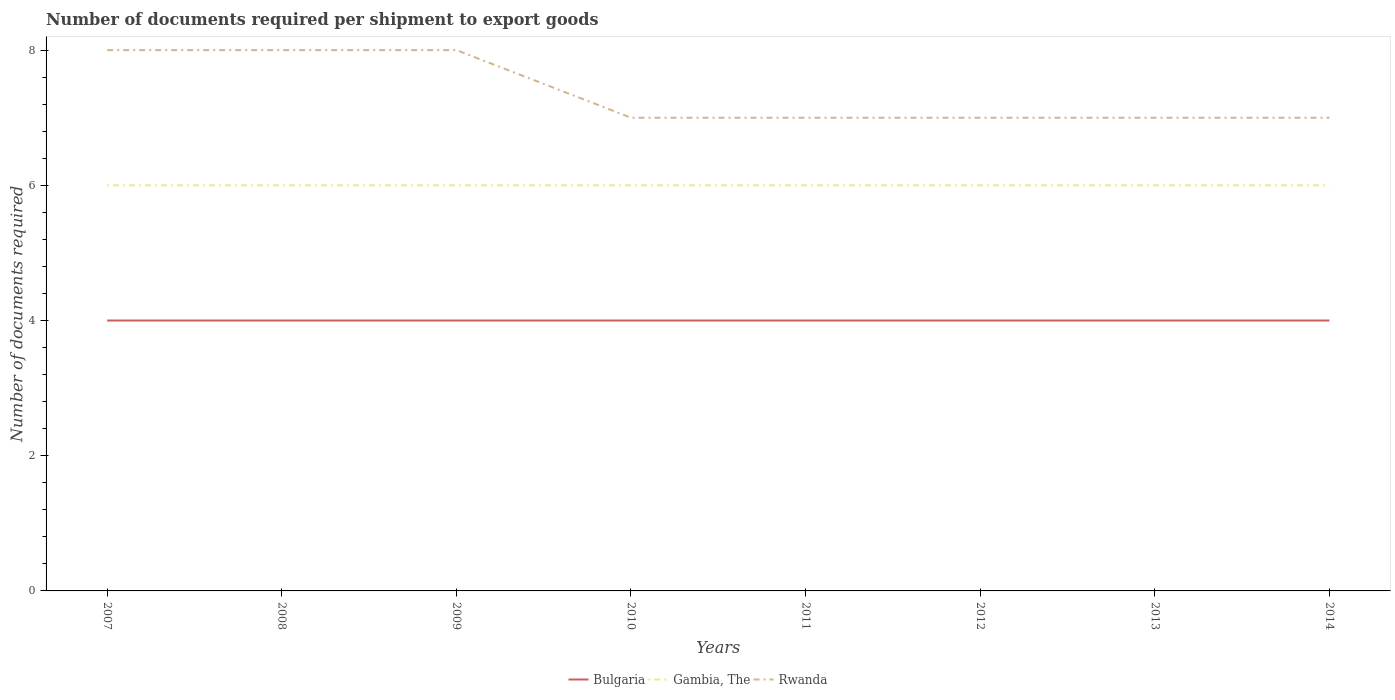How many different coloured lines are there?
Your response must be concise. 3. Is the number of lines equal to the number of legend labels?
Your answer should be very brief. Yes. Across all years, what is the maximum number of documents required per shipment to export goods in Rwanda?
Provide a succinct answer. 7. What is the total number of documents required per shipment to export goods in Rwanda in the graph?
Keep it short and to the point. 1. What is the difference between the highest and the second highest number of documents required per shipment to export goods in Bulgaria?
Your response must be concise. 0. Is the number of documents required per shipment to export goods in Bulgaria strictly greater than the number of documents required per shipment to export goods in Gambia, The over the years?
Ensure brevity in your answer.  Yes. How many years are there in the graph?
Provide a short and direct response. 8. Does the graph contain any zero values?
Keep it short and to the point. No. Where does the legend appear in the graph?
Provide a short and direct response. Bottom center. How many legend labels are there?
Your response must be concise. 3. What is the title of the graph?
Offer a very short reply. Number of documents required per shipment to export goods. Does "Montenegro" appear as one of the legend labels in the graph?
Offer a very short reply. No. What is the label or title of the X-axis?
Make the answer very short. Years. What is the label or title of the Y-axis?
Your answer should be very brief. Number of documents required. What is the Number of documents required of Bulgaria in 2007?
Offer a very short reply. 4. What is the Number of documents required in Gambia, The in 2007?
Your response must be concise. 6. What is the Number of documents required in Rwanda in 2007?
Your response must be concise. 8. What is the Number of documents required in Bulgaria in 2008?
Offer a terse response. 4. What is the Number of documents required in Gambia, The in 2008?
Offer a very short reply. 6. What is the Number of documents required in Bulgaria in 2009?
Keep it short and to the point. 4. What is the Number of documents required of Gambia, The in 2009?
Ensure brevity in your answer.  6. What is the Number of documents required in Rwanda in 2009?
Your response must be concise. 8. What is the Number of documents required of Rwanda in 2010?
Provide a succinct answer. 7. What is the Number of documents required of Rwanda in 2011?
Make the answer very short. 7. What is the Number of documents required of Gambia, The in 2012?
Your answer should be compact. 6. What is the Number of documents required in Rwanda in 2012?
Offer a very short reply. 7. What is the Number of documents required of Gambia, The in 2013?
Make the answer very short. 6. What is the Number of documents required in Rwanda in 2013?
Keep it short and to the point. 7. What is the Number of documents required in Gambia, The in 2014?
Make the answer very short. 6. Across all years, what is the maximum Number of documents required of Bulgaria?
Provide a short and direct response. 4. Across all years, what is the minimum Number of documents required in Gambia, The?
Provide a succinct answer. 6. Across all years, what is the minimum Number of documents required in Rwanda?
Give a very brief answer. 7. What is the total Number of documents required of Bulgaria in the graph?
Your answer should be very brief. 32. What is the difference between the Number of documents required in Gambia, The in 2007 and that in 2008?
Ensure brevity in your answer.  0. What is the difference between the Number of documents required of Gambia, The in 2007 and that in 2009?
Give a very brief answer. 0. What is the difference between the Number of documents required in Rwanda in 2007 and that in 2009?
Give a very brief answer. 0. What is the difference between the Number of documents required of Bulgaria in 2007 and that in 2013?
Make the answer very short. 0. What is the difference between the Number of documents required in Bulgaria in 2007 and that in 2014?
Your answer should be very brief. 0. What is the difference between the Number of documents required in Gambia, The in 2008 and that in 2009?
Your answer should be very brief. 0. What is the difference between the Number of documents required in Bulgaria in 2008 and that in 2010?
Offer a terse response. 0. What is the difference between the Number of documents required in Bulgaria in 2008 and that in 2011?
Ensure brevity in your answer.  0. What is the difference between the Number of documents required of Bulgaria in 2008 and that in 2012?
Your answer should be very brief. 0. What is the difference between the Number of documents required of Rwanda in 2008 and that in 2012?
Ensure brevity in your answer.  1. What is the difference between the Number of documents required in Bulgaria in 2008 and that in 2013?
Offer a very short reply. 0. What is the difference between the Number of documents required of Bulgaria in 2008 and that in 2014?
Provide a succinct answer. 0. What is the difference between the Number of documents required in Gambia, The in 2009 and that in 2010?
Offer a very short reply. 0. What is the difference between the Number of documents required in Rwanda in 2009 and that in 2010?
Provide a succinct answer. 1. What is the difference between the Number of documents required of Bulgaria in 2009 and that in 2011?
Offer a terse response. 0. What is the difference between the Number of documents required in Rwanda in 2009 and that in 2011?
Ensure brevity in your answer.  1. What is the difference between the Number of documents required of Rwanda in 2009 and that in 2012?
Offer a terse response. 1. What is the difference between the Number of documents required in Bulgaria in 2009 and that in 2013?
Provide a short and direct response. 0. What is the difference between the Number of documents required in Rwanda in 2009 and that in 2013?
Your response must be concise. 1. What is the difference between the Number of documents required of Rwanda in 2009 and that in 2014?
Offer a terse response. 1. What is the difference between the Number of documents required of Gambia, The in 2010 and that in 2011?
Your response must be concise. 0. What is the difference between the Number of documents required in Bulgaria in 2010 and that in 2012?
Provide a short and direct response. 0. What is the difference between the Number of documents required of Bulgaria in 2010 and that in 2013?
Your response must be concise. 0. What is the difference between the Number of documents required in Gambia, The in 2010 and that in 2013?
Your response must be concise. 0. What is the difference between the Number of documents required of Bulgaria in 2010 and that in 2014?
Give a very brief answer. 0. What is the difference between the Number of documents required of Gambia, The in 2010 and that in 2014?
Make the answer very short. 0. What is the difference between the Number of documents required in Rwanda in 2010 and that in 2014?
Make the answer very short. 0. What is the difference between the Number of documents required of Bulgaria in 2011 and that in 2012?
Your answer should be compact. 0. What is the difference between the Number of documents required in Gambia, The in 2011 and that in 2012?
Offer a terse response. 0. What is the difference between the Number of documents required of Bulgaria in 2011 and that in 2013?
Ensure brevity in your answer.  0. What is the difference between the Number of documents required of Rwanda in 2011 and that in 2013?
Make the answer very short. 0. What is the difference between the Number of documents required of Bulgaria in 2011 and that in 2014?
Offer a terse response. 0. What is the difference between the Number of documents required of Gambia, The in 2012 and that in 2013?
Give a very brief answer. 0. What is the difference between the Number of documents required in Rwanda in 2012 and that in 2014?
Provide a succinct answer. 0. What is the difference between the Number of documents required of Bulgaria in 2013 and that in 2014?
Keep it short and to the point. 0. What is the difference between the Number of documents required in Gambia, The in 2013 and that in 2014?
Make the answer very short. 0. What is the difference between the Number of documents required in Rwanda in 2013 and that in 2014?
Your answer should be very brief. 0. What is the difference between the Number of documents required of Bulgaria in 2007 and the Number of documents required of Rwanda in 2008?
Ensure brevity in your answer.  -4. What is the difference between the Number of documents required in Gambia, The in 2007 and the Number of documents required in Rwanda in 2008?
Your response must be concise. -2. What is the difference between the Number of documents required in Bulgaria in 2007 and the Number of documents required in Rwanda in 2009?
Your response must be concise. -4. What is the difference between the Number of documents required in Gambia, The in 2007 and the Number of documents required in Rwanda in 2009?
Your answer should be very brief. -2. What is the difference between the Number of documents required in Bulgaria in 2007 and the Number of documents required in Rwanda in 2010?
Your response must be concise. -3. What is the difference between the Number of documents required in Gambia, The in 2007 and the Number of documents required in Rwanda in 2010?
Your response must be concise. -1. What is the difference between the Number of documents required in Bulgaria in 2007 and the Number of documents required in Gambia, The in 2011?
Give a very brief answer. -2. What is the difference between the Number of documents required in Bulgaria in 2007 and the Number of documents required in Rwanda in 2011?
Make the answer very short. -3. What is the difference between the Number of documents required of Gambia, The in 2007 and the Number of documents required of Rwanda in 2011?
Give a very brief answer. -1. What is the difference between the Number of documents required in Bulgaria in 2007 and the Number of documents required in Gambia, The in 2012?
Keep it short and to the point. -2. What is the difference between the Number of documents required in Bulgaria in 2007 and the Number of documents required in Rwanda in 2012?
Offer a terse response. -3. What is the difference between the Number of documents required of Gambia, The in 2007 and the Number of documents required of Rwanda in 2012?
Offer a terse response. -1. What is the difference between the Number of documents required in Bulgaria in 2007 and the Number of documents required in Gambia, The in 2013?
Keep it short and to the point. -2. What is the difference between the Number of documents required in Gambia, The in 2007 and the Number of documents required in Rwanda in 2014?
Your answer should be compact. -1. What is the difference between the Number of documents required in Bulgaria in 2008 and the Number of documents required in Rwanda in 2009?
Offer a very short reply. -4. What is the difference between the Number of documents required in Bulgaria in 2008 and the Number of documents required in Gambia, The in 2010?
Your answer should be very brief. -2. What is the difference between the Number of documents required of Bulgaria in 2008 and the Number of documents required of Rwanda in 2010?
Give a very brief answer. -3. What is the difference between the Number of documents required of Gambia, The in 2008 and the Number of documents required of Rwanda in 2010?
Ensure brevity in your answer.  -1. What is the difference between the Number of documents required in Bulgaria in 2008 and the Number of documents required in Gambia, The in 2011?
Provide a short and direct response. -2. What is the difference between the Number of documents required in Bulgaria in 2008 and the Number of documents required in Rwanda in 2012?
Offer a very short reply. -3. What is the difference between the Number of documents required in Bulgaria in 2008 and the Number of documents required in Rwanda in 2013?
Your response must be concise. -3. What is the difference between the Number of documents required of Gambia, The in 2008 and the Number of documents required of Rwanda in 2013?
Your answer should be very brief. -1. What is the difference between the Number of documents required of Bulgaria in 2009 and the Number of documents required of Rwanda in 2010?
Give a very brief answer. -3. What is the difference between the Number of documents required in Gambia, The in 2009 and the Number of documents required in Rwanda in 2010?
Ensure brevity in your answer.  -1. What is the difference between the Number of documents required of Bulgaria in 2009 and the Number of documents required of Gambia, The in 2012?
Ensure brevity in your answer.  -2. What is the difference between the Number of documents required in Bulgaria in 2009 and the Number of documents required in Rwanda in 2012?
Keep it short and to the point. -3. What is the difference between the Number of documents required of Gambia, The in 2009 and the Number of documents required of Rwanda in 2012?
Offer a terse response. -1. What is the difference between the Number of documents required of Bulgaria in 2009 and the Number of documents required of Rwanda in 2013?
Keep it short and to the point. -3. What is the difference between the Number of documents required in Gambia, The in 2009 and the Number of documents required in Rwanda in 2014?
Provide a short and direct response. -1. What is the difference between the Number of documents required of Gambia, The in 2010 and the Number of documents required of Rwanda in 2011?
Your answer should be very brief. -1. What is the difference between the Number of documents required of Gambia, The in 2010 and the Number of documents required of Rwanda in 2012?
Your answer should be compact. -1. What is the difference between the Number of documents required of Bulgaria in 2010 and the Number of documents required of Rwanda in 2013?
Keep it short and to the point. -3. What is the difference between the Number of documents required in Bulgaria in 2011 and the Number of documents required in Gambia, The in 2012?
Offer a very short reply. -2. What is the difference between the Number of documents required in Gambia, The in 2011 and the Number of documents required in Rwanda in 2012?
Keep it short and to the point. -1. What is the difference between the Number of documents required in Bulgaria in 2011 and the Number of documents required in Gambia, The in 2013?
Your response must be concise. -2. What is the difference between the Number of documents required of Gambia, The in 2011 and the Number of documents required of Rwanda in 2013?
Make the answer very short. -1. What is the difference between the Number of documents required in Bulgaria in 2011 and the Number of documents required in Rwanda in 2014?
Your response must be concise. -3. What is the difference between the Number of documents required in Bulgaria in 2012 and the Number of documents required in Rwanda in 2013?
Offer a terse response. -3. What is the difference between the Number of documents required in Gambia, The in 2012 and the Number of documents required in Rwanda in 2014?
Offer a very short reply. -1. What is the difference between the Number of documents required of Bulgaria in 2013 and the Number of documents required of Rwanda in 2014?
Your answer should be very brief. -3. What is the difference between the Number of documents required of Gambia, The in 2013 and the Number of documents required of Rwanda in 2014?
Offer a very short reply. -1. What is the average Number of documents required in Gambia, The per year?
Your answer should be very brief. 6. What is the average Number of documents required in Rwanda per year?
Your answer should be compact. 7.38. In the year 2007, what is the difference between the Number of documents required of Bulgaria and Number of documents required of Gambia, The?
Your answer should be compact. -2. In the year 2007, what is the difference between the Number of documents required in Bulgaria and Number of documents required in Rwanda?
Offer a terse response. -4. In the year 2008, what is the difference between the Number of documents required of Bulgaria and Number of documents required of Gambia, The?
Provide a short and direct response. -2. In the year 2008, what is the difference between the Number of documents required in Bulgaria and Number of documents required in Rwanda?
Your answer should be very brief. -4. In the year 2009, what is the difference between the Number of documents required in Gambia, The and Number of documents required in Rwanda?
Your answer should be compact. -2. In the year 2010, what is the difference between the Number of documents required in Gambia, The and Number of documents required in Rwanda?
Your response must be concise. -1. In the year 2011, what is the difference between the Number of documents required of Bulgaria and Number of documents required of Gambia, The?
Your response must be concise. -2. In the year 2011, what is the difference between the Number of documents required in Bulgaria and Number of documents required in Rwanda?
Make the answer very short. -3. In the year 2012, what is the difference between the Number of documents required of Bulgaria and Number of documents required of Gambia, The?
Keep it short and to the point. -2. In the year 2012, what is the difference between the Number of documents required in Bulgaria and Number of documents required in Rwanda?
Make the answer very short. -3. In the year 2013, what is the difference between the Number of documents required in Bulgaria and Number of documents required in Gambia, The?
Provide a short and direct response. -2. In the year 2013, what is the difference between the Number of documents required in Bulgaria and Number of documents required in Rwanda?
Provide a succinct answer. -3. In the year 2013, what is the difference between the Number of documents required in Gambia, The and Number of documents required in Rwanda?
Keep it short and to the point. -1. In the year 2014, what is the difference between the Number of documents required of Bulgaria and Number of documents required of Gambia, The?
Provide a short and direct response. -2. In the year 2014, what is the difference between the Number of documents required in Bulgaria and Number of documents required in Rwanda?
Make the answer very short. -3. In the year 2014, what is the difference between the Number of documents required in Gambia, The and Number of documents required in Rwanda?
Your answer should be very brief. -1. What is the ratio of the Number of documents required in Bulgaria in 2007 to that in 2008?
Your response must be concise. 1. What is the ratio of the Number of documents required in Rwanda in 2007 to that in 2008?
Give a very brief answer. 1. What is the ratio of the Number of documents required in Rwanda in 2007 to that in 2010?
Provide a short and direct response. 1.14. What is the ratio of the Number of documents required of Bulgaria in 2007 to that in 2011?
Your answer should be very brief. 1. What is the ratio of the Number of documents required in Rwanda in 2007 to that in 2012?
Keep it short and to the point. 1.14. What is the ratio of the Number of documents required in Bulgaria in 2007 to that in 2013?
Provide a short and direct response. 1. What is the ratio of the Number of documents required of Gambia, The in 2007 to that in 2013?
Make the answer very short. 1. What is the ratio of the Number of documents required of Rwanda in 2007 to that in 2013?
Offer a terse response. 1.14. What is the ratio of the Number of documents required in Bulgaria in 2007 to that in 2014?
Your answer should be very brief. 1. What is the ratio of the Number of documents required in Gambia, The in 2007 to that in 2014?
Your answer should be very brief. 1. What is the ratio of the Number of documents required of Gambia, The in 2008 to that in 2009?
Your answer should be very brief. 1. What is the ratio of the Number of documents required in Bulgaria in 2008 to that in 2010?
Provide a succinct answer. 1. What is the ratio of the Number of documents required in Gambia, The in 2008 to that in 2011?
Ensure brevity in your answer.  1. What is the ratio of the Number of documents required in Bulgaria in 2008 to that in 2012?
Your response must be concise. 1. What is the ratio of the Number of documents required in Rwanda in 2008 to that in 2012?
Provide a short and direct response. 1.14. What is the ratio of the Number of documents required of Rwanda in 2008 to that in 2013?
Your answer should be compact. 1.14. What is the ratio of the Number of documents required in Bulgaria in 2008 to that in 2014?
Make the answer very short. 1. What is the ratio of the Number of documents required in Gambia, The in 2008 to that in 2014?
Your answer should be very brief. 1. What is the ratio of the Number of documents required of Bulgaria in 2009 to that in 2010?
Ensure brevity in your answer.  1. What is the ratio of the Number of documents required in Gambia, The in 2009 to that in 2010?
Offer a very short reply. 1. What is the ratio of the Number of documents required of Rwanda in 2009 to that in 2010?
Offer a terse response. 1.14. What is the ratio of the Number of documents required in Gambia, The in 2009 to that in 2011?
Your response must be concise. 1. What is the ratio of the Number of documents required in Rwanda in 2009 to that in 2011?
Provide a short and direct response. 1.14. What is the ratio of the Number of documents required in Gambia, The in 2009 to that in 2012?
Keep it short and to the point. 1. What is the ratio of the Number of documents required in Rwanda in 2009 to that in 2012?
Offer a terse response. 1.14. What is the ratio of the Number of documents required of Bulgaria in 2009 to that in 2013?
Your answer should be very brief. 1. What is the ratio of the Number of documents required of Gambia, The in 2009 to that in 2013?
Keep it short and to the point. 1. What is the ratio of the Number of documents required of Bulgaria in 2010 to that in 2011?
Your response must be concise. 1. What is the ratio of the Number of documents required in Gambia, The in 2010 to that in 2011?
Make the answer very short. 1. What is the ratio of the Number of documents required of Gambia, The in 2010 to that in 2012?
Provide a short and direct response. 1. What is the ratio of the Number of documents required in Rwanda in 2010 to that in 2012?
Offer a terse response. 1. What is the ratio of the Number of documents required of Bulgaria in 2010 to that in 2013?
Offer a terse response. 1. What is the ratio of the Number of documents required of Rwanda in 2010 to that in 2013?
Ensure brevity in your answer.  1. What is the ratio of the Number of documents required of Bulgaria in 2010 to that in 2014?
Your answer should be very brief. 1. What is the ratio of the Number of documents required in Gambia, The in 2010 to that in 2014?
Provide a succinct answer. 1. What is the ratio of the Number of documents required in Rwanda in 2010 to that in 2014?
Offer a very short reply. 1. What is the ratio of the Number of documents required in Rwanda in 2011 to that in 2012?
Your answer should be very brief. 1. What is the ratio of the Number of documents required in Gambia, The in 2011 to that in 2014?
Ensure brevity in your answer.  1. What is the ratio of the Number of documents required in Bulgaria in 2012 to that in 2013?
Your answer should be very brief. 1. What is the ratio of the Number of documents required in Rwanda in 2012 to that in 2013?
Your answer should be very brief. 1. What is the ratio of the Number of documents required in Gambia, The in 2013 to that in 2014?
Your answer should be compact. 1. What is the difference between the highest and the second highest Number of documents required in Bulgaria?
Your answer should be very brief. 0. What is the difference between the highest and the second highest Number of documents required of Gambia, The?
Your response must be concise. 0. What is the difference between the highest and the second highest Number of documents required of Rwanda?
Offer a terse response. 0. 